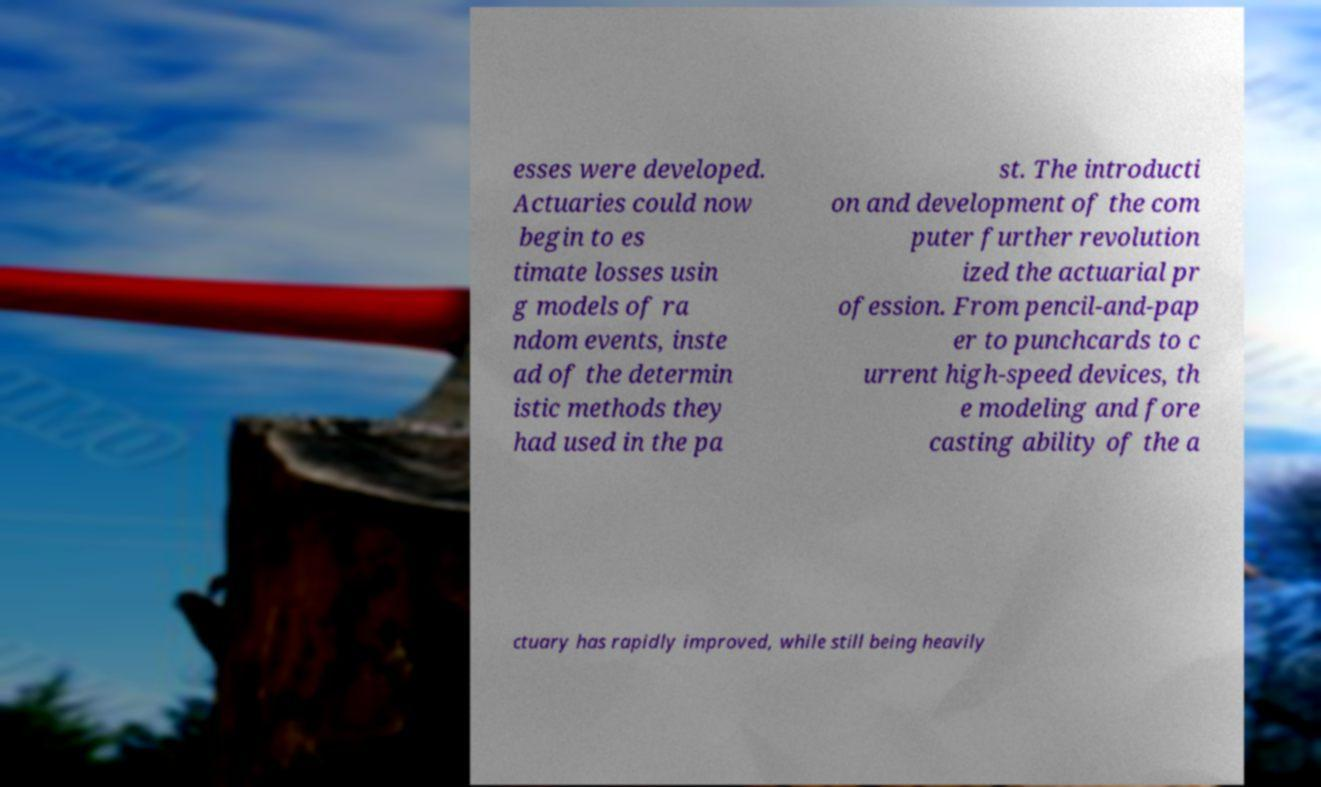Please read and relay the text visible in this image. What does it say? esses were developed. Actuaries could now begin to es timate losses usin g models of ra ndom events, inste ad of the determin istic methods they had used in the pa st. The introducti on and development of the com puter further revolution ized the actuarial pr ofession. From pencil-and-pap er to punchcards to c urrent high-speed devices, th e modeling and fore casting ability of the a ctuary has rapidly improved, while still being heavily 